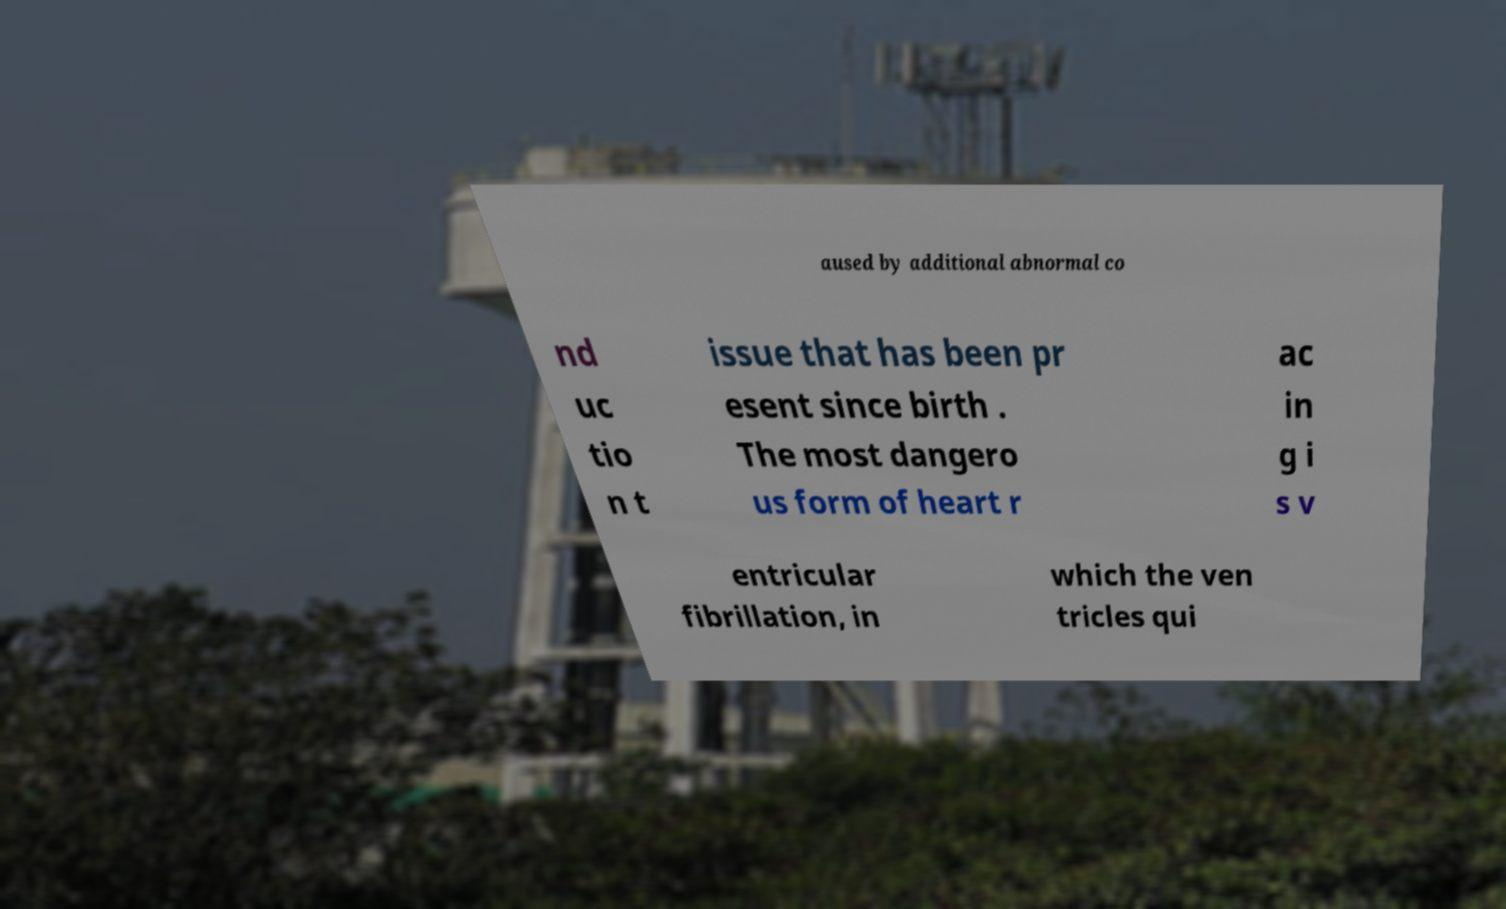I need the written content from this picture converted into text. Can you do that? aused by additional abnormal co nd uc tio n t issue that has been pr esent since birth . The most dangero us form of heart r ac in g i s v entricular fibrillation, in which the ven tricles qui 